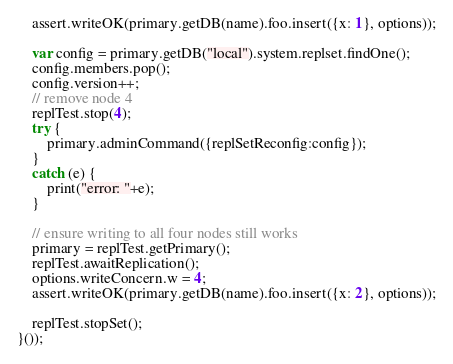<code> <loc_0><loc_0><loc_500><loc_500><_JavaScript_>    assert.writeOK(primary.getDB(name).foo.insert({x: 1}, options));

    var config = primary.getDB("local").system.replset.findOne();
    config.members.pop();
    config.version++;
    // remove node 4
    replTest.stop(4);
    try {
        primary.adminCommand({replSetReconfig:config});
    }
    catch (e) {
        print("error: "+e);
    }

    // ensure writing to all four nodes still works
    primary = replTest.getPrimary();
    replTest.awaitReplication();
    options.writeConcern.w = 4;
    assert.writeOK(primary.getDB(name).foo.insert({x: 2}, options));
    
    replTest.stopSet();
}());
</code> 